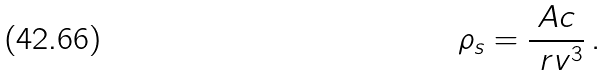<formula> <loc_0><loc_0><loc_500><loc_500>\rho _ { s } = \frac { A c } { \ r v ^ { 3 } } \, .</formula> 